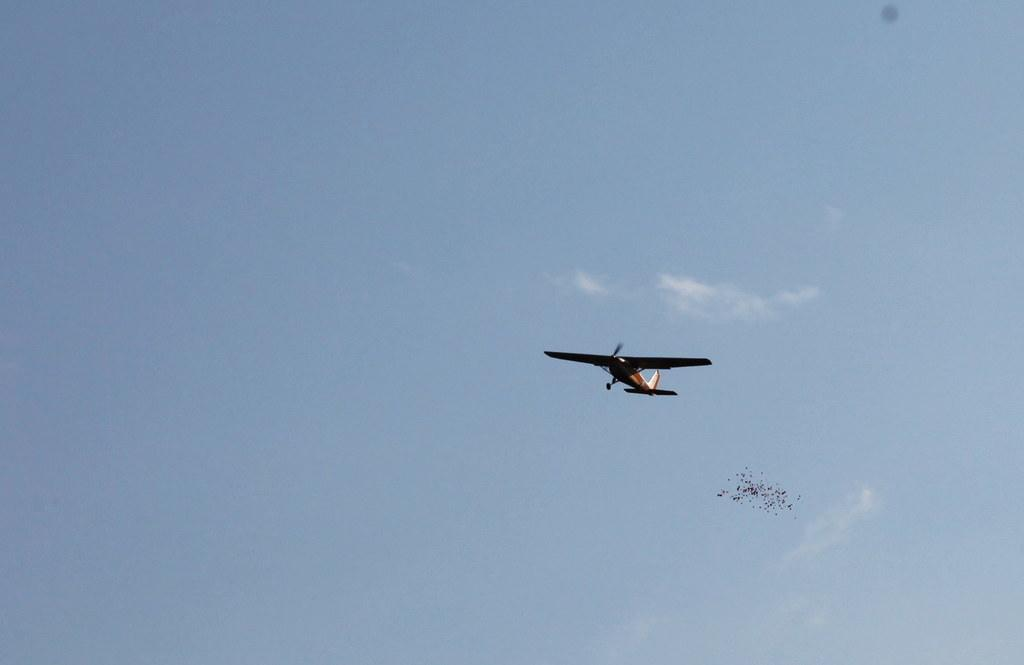Where was the image taken? The image was taken outdoors. What can be seen in the background of the image? There is a sky with clouds visible in the background. What is happening in the sky in the image? An airplane is flying in the sky, and there are birds flying as well. What type of zephyr is present in the image? There is no mention of a zephyr in the image, as it refers to a gentle breeze, which is not visible in the image. 